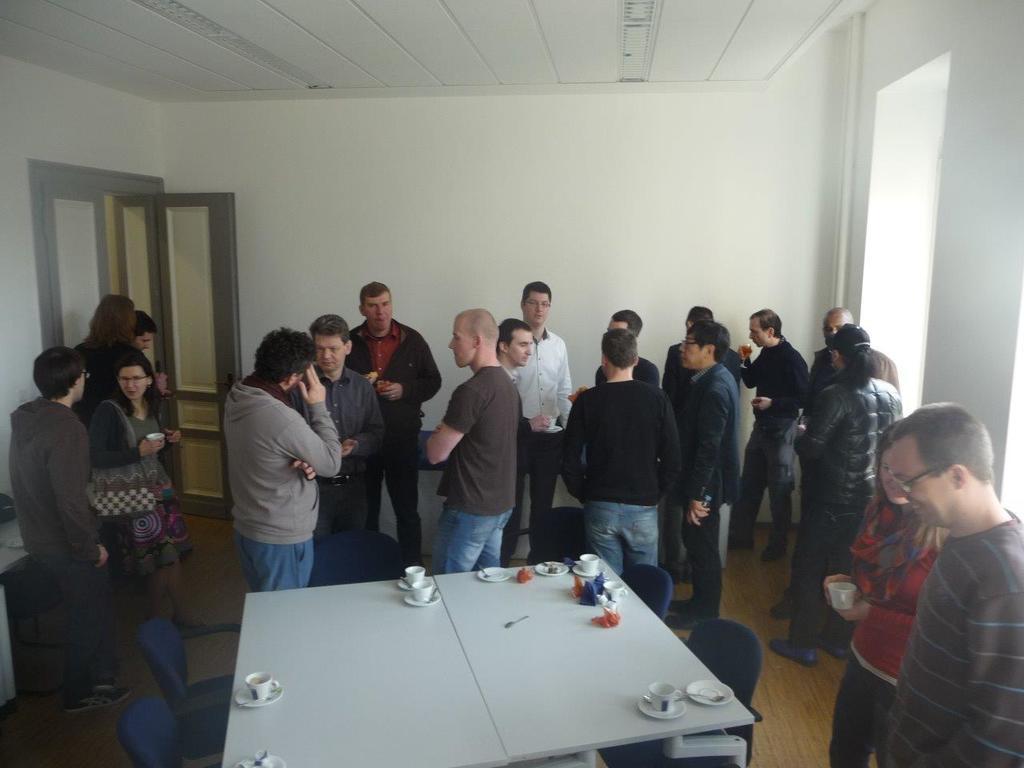Describe this image in one or two sentences. In this picture we can see a group of people standing and talking to each other holding cups in their hands and in between them there are chairs and table on table we can see cups, saucer, papers, spoon and in background we can see door, wall, window. 